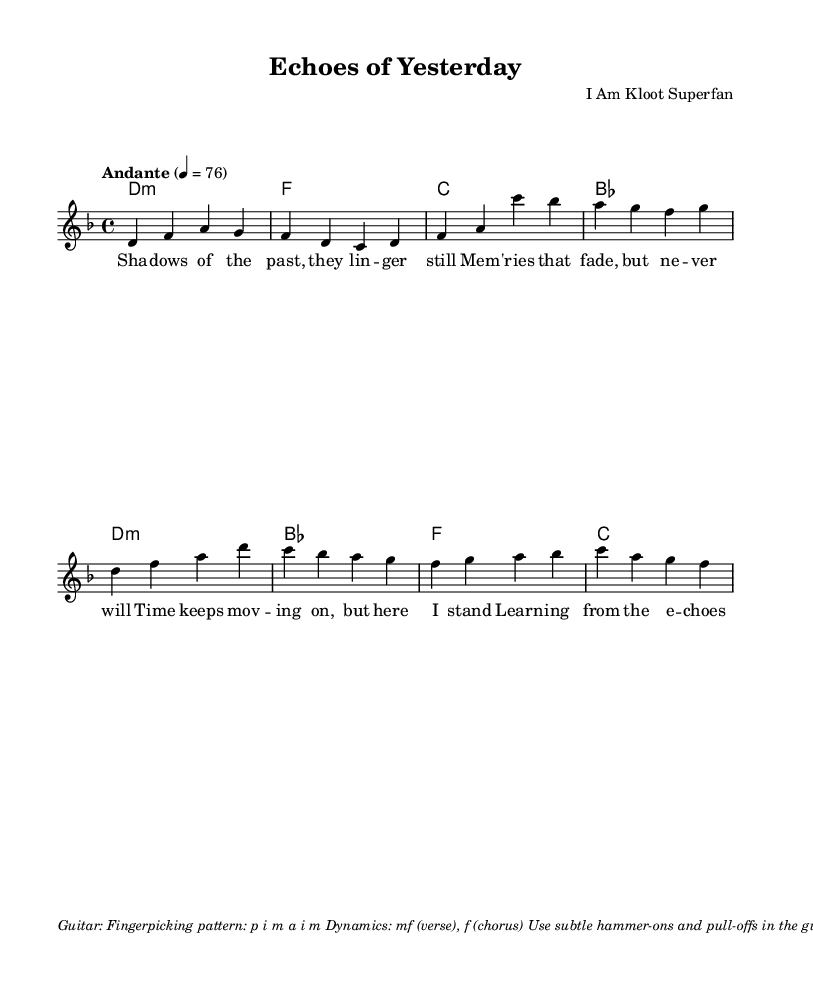What is the key signature of this music? The key signature indicates one flat, which corresponds to D minor. It is determined by looking at the key signature section at the beginning of the sheet music.
Answer: D minor What is the time signature of this piece? The time signature is found at the beginning of the score, shown as 4/4, meaning there are four beats in each measure, and the quarter note receives one beat.
Answer: 4/4 What is the tempo marking of the piece? The tempo marking is stated as "Andante" with a metronome marking of 76 beats per minute. This indicates a moderately slow pace.
Answer: Andante, 76 What are the dynamics for the verse and chorus? The dynamics are specified in the markup section, indicating that verses should be played at mezzo-forte (mf) and the chorus at forte (f), suggesting a gradual increase in intensity during the chorus.
Answer: mf (verse), f (chorus) How many measures are in the verse? The verse consists of four measures, as can be counted from the melody section provided, where lines are divided into four distinct rhythmic groups.
Answer: 4 What is the primary thematic focus of the lyrics in this song? The lyrics reflect on memories and personal growth, emphasizing themes of change and reflection. This is evident from the content of the lyrics that describe looking back while moving forward.
Answer: Memories and personal growth What style of guitar playing is suggested in the markup? The guitar part suggests a fingerpicking pattern using the fingers indicated (p i m a i m) along with techniques like hammer-ons and pull-offs to enhance the texture, characteristic of an intimate performance style.
Answer: Fingerpicking 